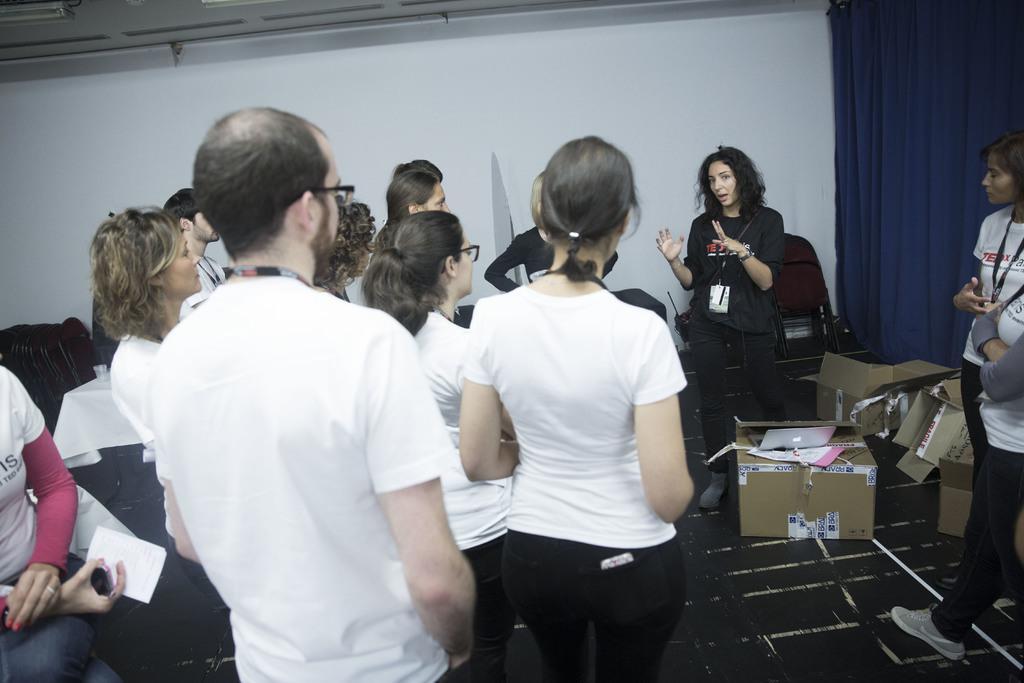In one or two sentences, can you explain what this image depicts? In this picture we can see few people, carton boxes, chairs, and curtain. In the background we can see a wall. 